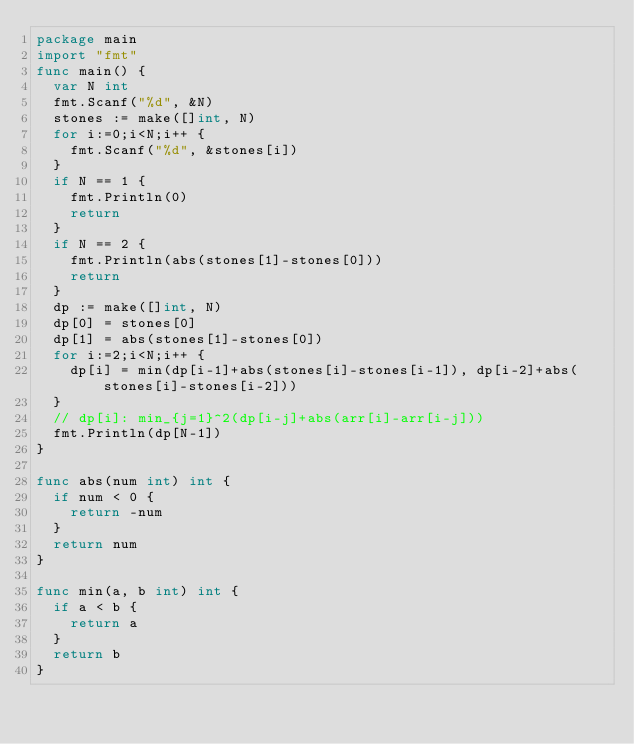<code> <loc_0><loc_0><loc_500><loc_500><_Go_>package main
import "fmt"
func main() {
  var N int
  fmt.Scanf("%d", &N)
  stones := make([]int, N)
  for i:=0;i<N;i++ {
    fmt.Scanf("%d", &stones[i])
  }
  if N == 1 {
    fmt.Println(0)
    return
  }
  if N == 2 {
    fmt.Println(abs(stones[1]-stones[0]))
    return
  }
  dp := make([]int, N)
  dp[0] = stones[0]
  dp[1] = abs(stones[1]-stones[0])
  for i:=2;i<N;i++ {
    dp[i] = min(dp[i-1]+abs(stones[i]-stones[i-1]), dp[i-2]+abs(stones[i]-stones[i-2]))
  }
  // dp[i]: min_{j=1}^2(dp[i-j]+abs(arr[i]-arr[i-j]))
  fmt.Println(dp[N-1])
}

func abs(num int) int {
  if num < 0 {
    return -num
  }
  return num
}

func min(a, b int) int {
  if a < b {
    return a
  }
  return b
}
</code> 